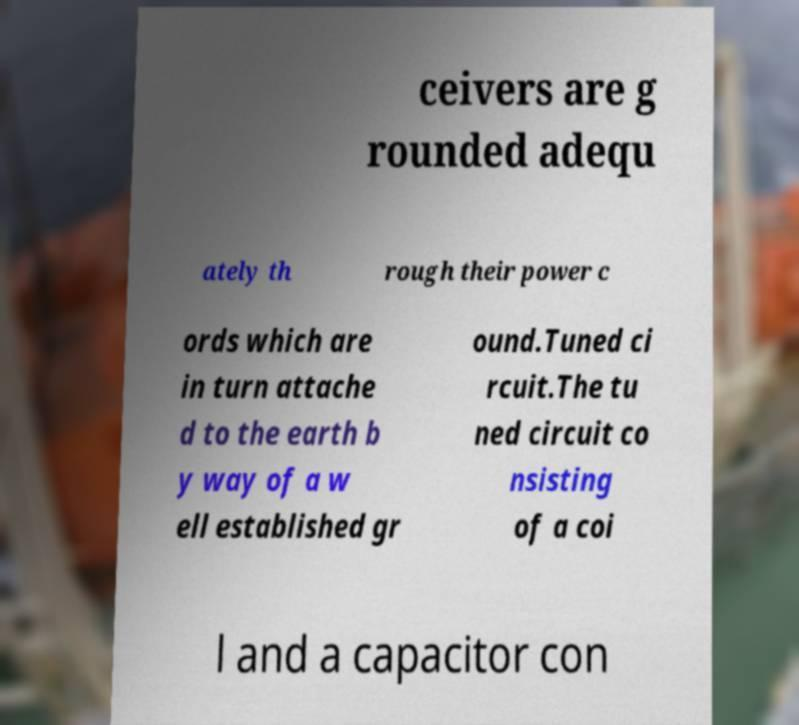There's text embedded in this image that I need extracted. Can you transcribe it verbatim? ceivers are g rounded adequ ately th rough their power c ords which are in turn attache d to the earth b y way of a w ell established gr ound.Tuned ci rcuit.The tu ned circuit co nsisting of a coi l and a capacitor con 